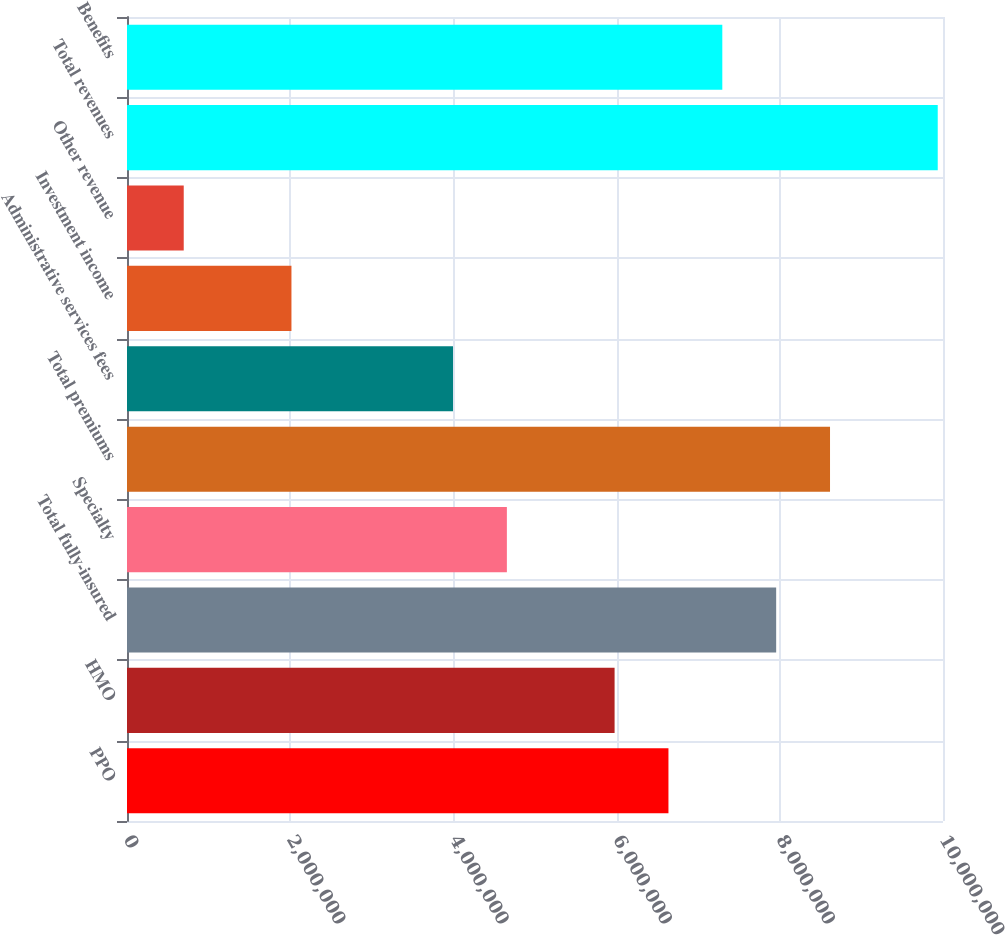<chart> <loc_0><loc_0><loc_500><loc_500><bar_chart><fcel>PPO<fcel>HMO<fcel>Total fully-insured<fcel>Specialty<fcel>Total premiums<fcel>Administrative services fees<fcel>Investment income<fcel>Other revenue<fcel>Total revenues<fcel>Benefits<nl><fcel>6.63542e+06<fcel>5.9754e+06<fcel>7.95546e+06<fcel>4.65536e+06<fcel>8.61548e+06<fcel>3.99534e+06<fcel>2.01529e+06<fcel>695248<fcel>9.93551e+06<fcel>7.29544e+06<nl></chart> 